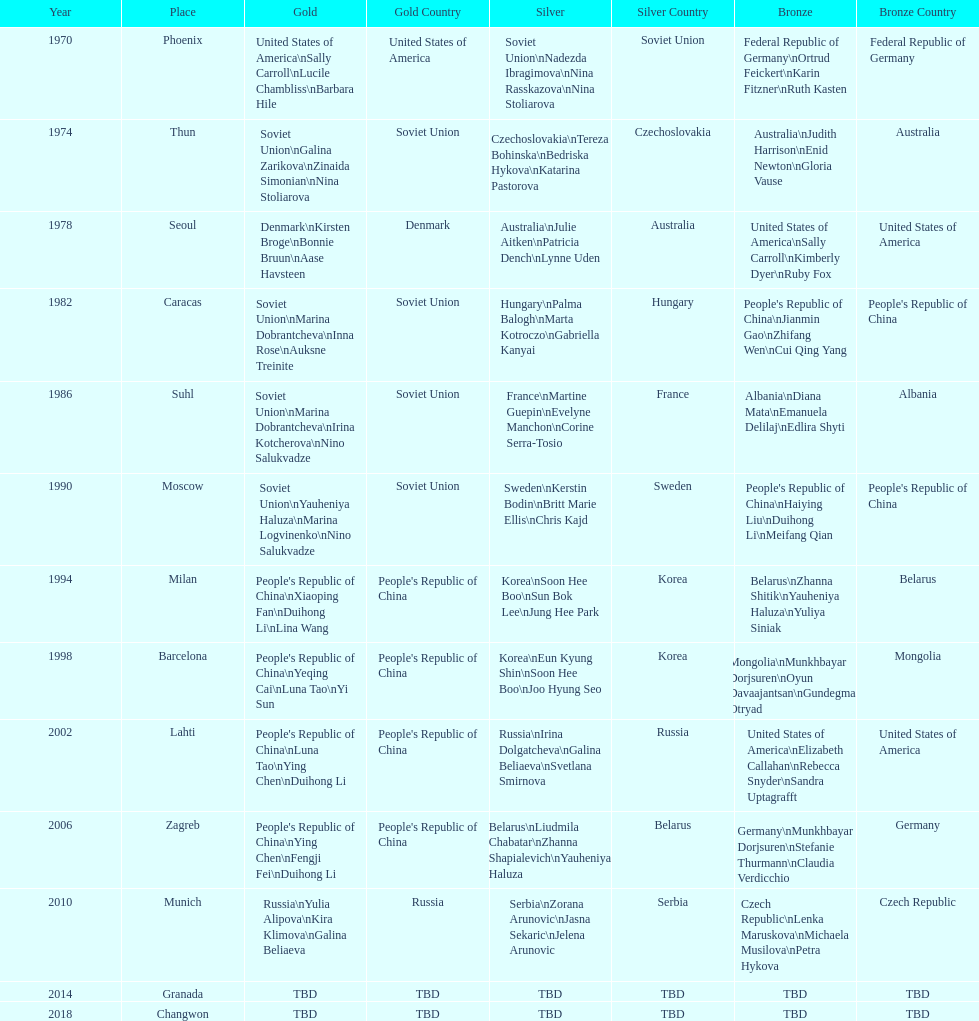Name one of the top three women to earn gold at the 1970 world championship held in phoenix, az Sally Carroll. 